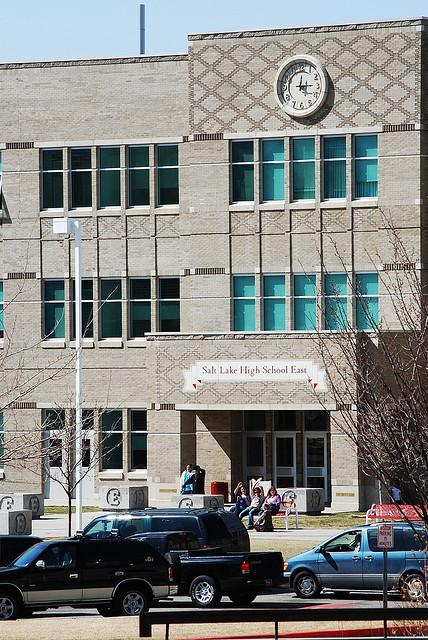What age people mostly utilize this space? teens 